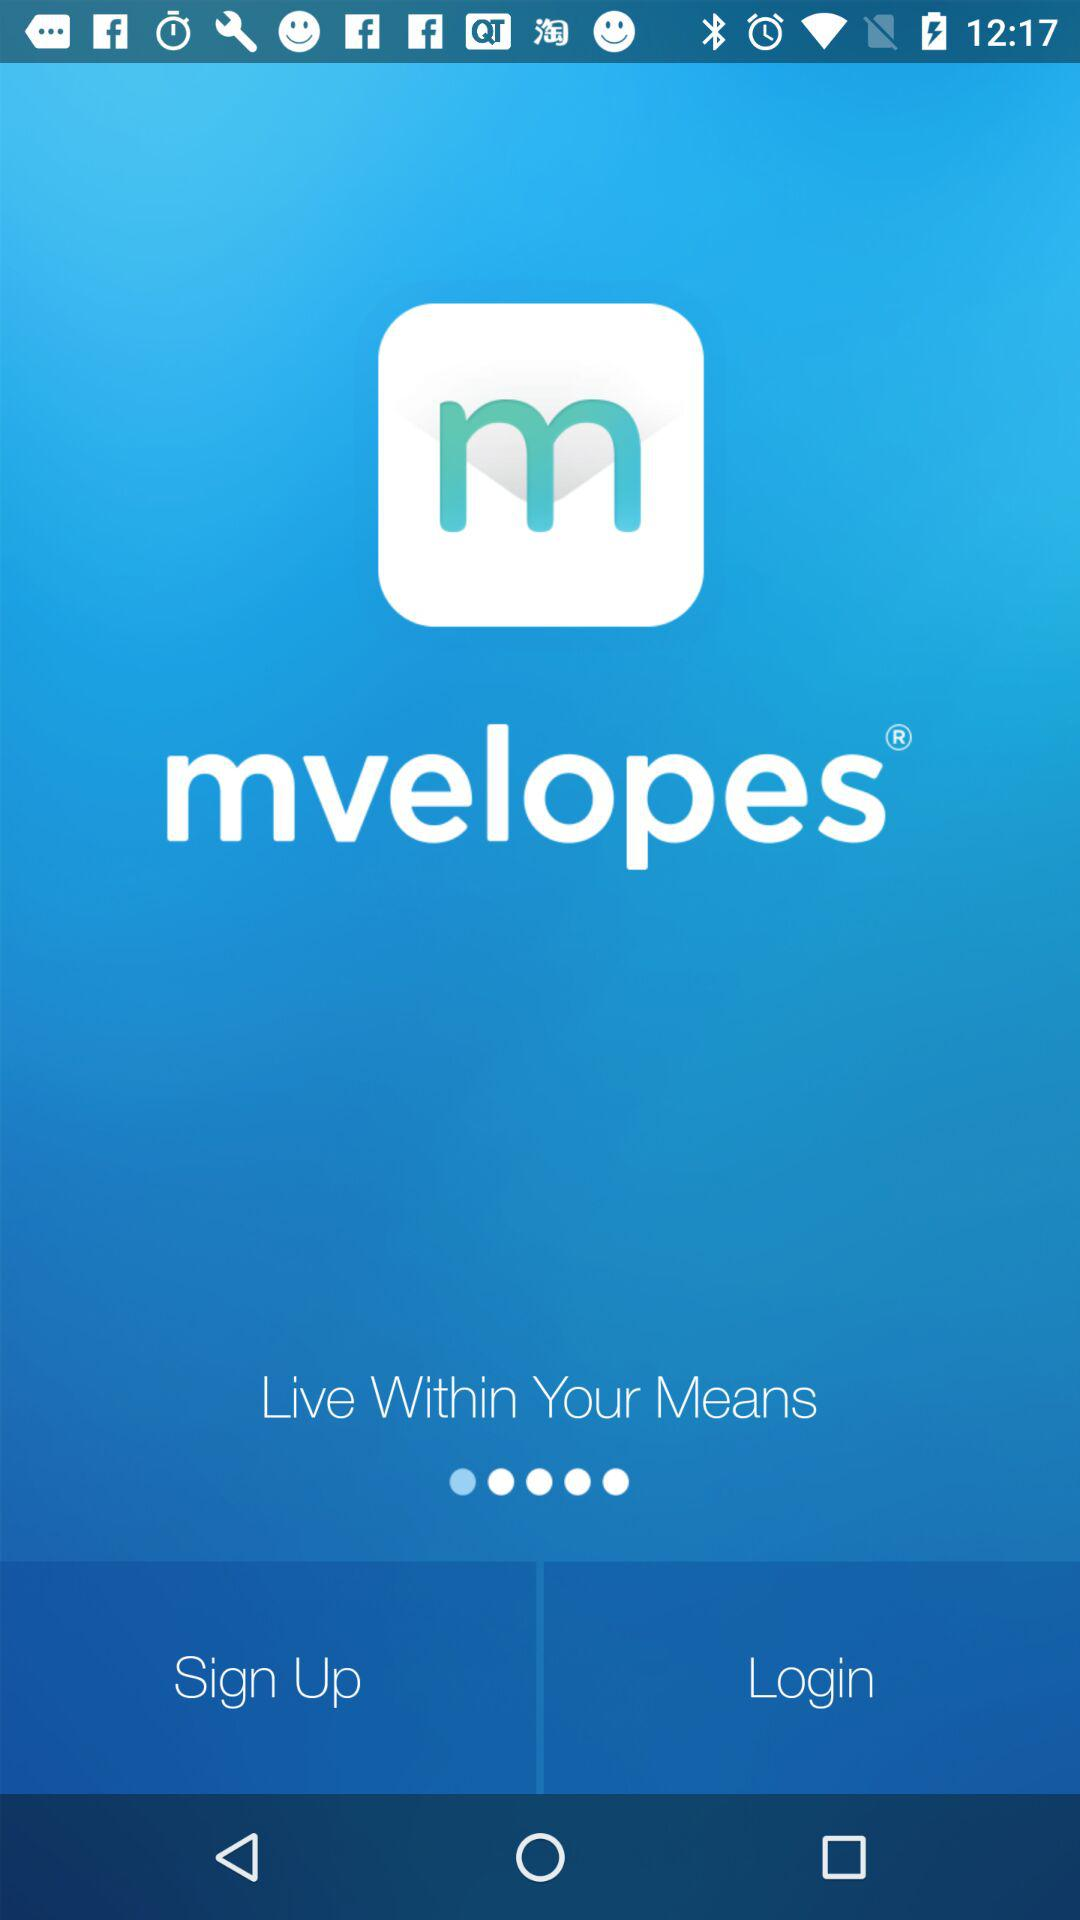What is the name of the application? The name of the application is "mvelopes". 